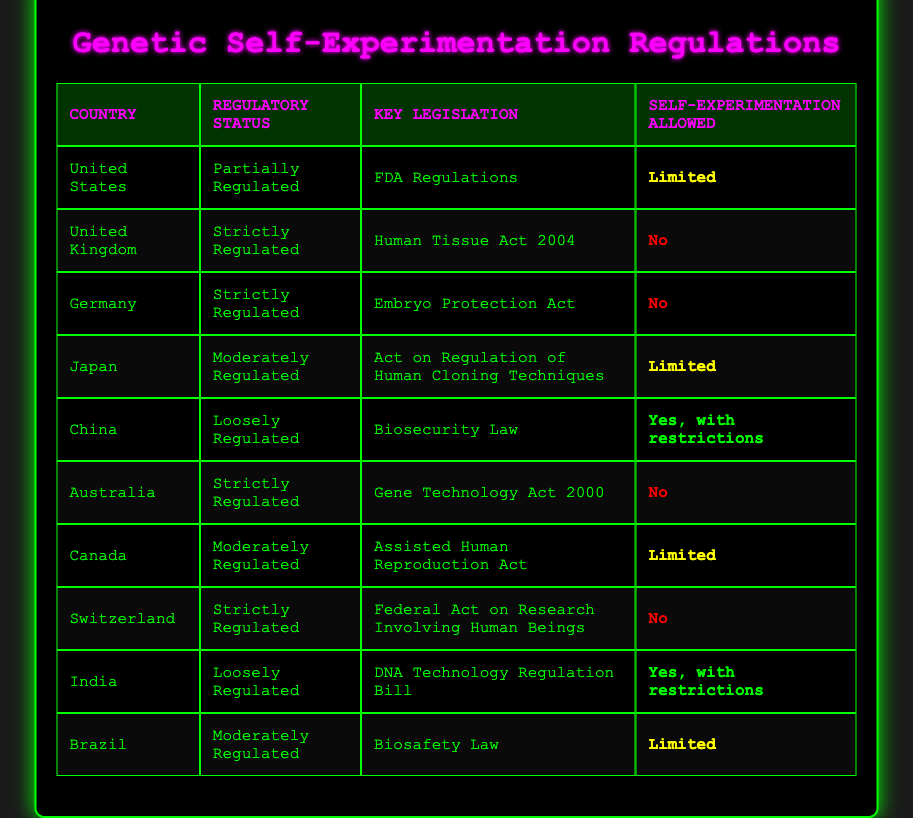What is the regulatory status of genetic self-experimentation in the United States? According to the table, the United States has a "Partially Regulated" status regarding genetic self-experimentation.
Answer: Partially Regulated Which country has the strictest regulations on genetic self-experimentation? The table shows that the United Kingdom, Germany, Australia, and Switzerland are all classified under "Strictly Regulated," but the UK has the strictest stance, with no allowance for self-experimentation.
Answer: United Kingdom How many countries allow self-experimentation with genetic engineering, but with restrictions? The table identifies two countries that allow self-experimentation with restrictions: China and India. Thus, the count is 2.
Answer: 2 What is the key legislation governing genetic self-experimentation in Canada? The table lists "Assisted Human Reproduction Act" as the key legislation in Canada for the regulation of genetic self-experimentation.
Answer: Assisted Human Reproduction Act Which country has a "Loosely Regulated" status and allows self-experimentation? China and India both have a "Loosely Regulated" status, but only China has "Yes, with restrictions" for self-experimentation.
Answer: China Are there any countries where self-experimentation is completely allowed? The table indicates that there are no countries where self-experimentation is completely allowed without any restrictions.
Answer: No What percentage of the listed countries allow limited self-experimentation? Out of the 10 countries, 4 (the United States, Japan, Canada, Brazil) allow limited self-experimentation, which is 40%.
Answer: 40% If self-experimentation is not allowed in a country, is it always strictly regulated? From the table, the United Kingdom, Germany, Australia, and Switzerland do not allow self-experimentation and are strictly regulated. However, it can be seen that some countries like the United States and Canada are partially or moderately regulated yet still allow limited self-experimentation. Therefore, it is not always strictly regulated.
Answer: No 